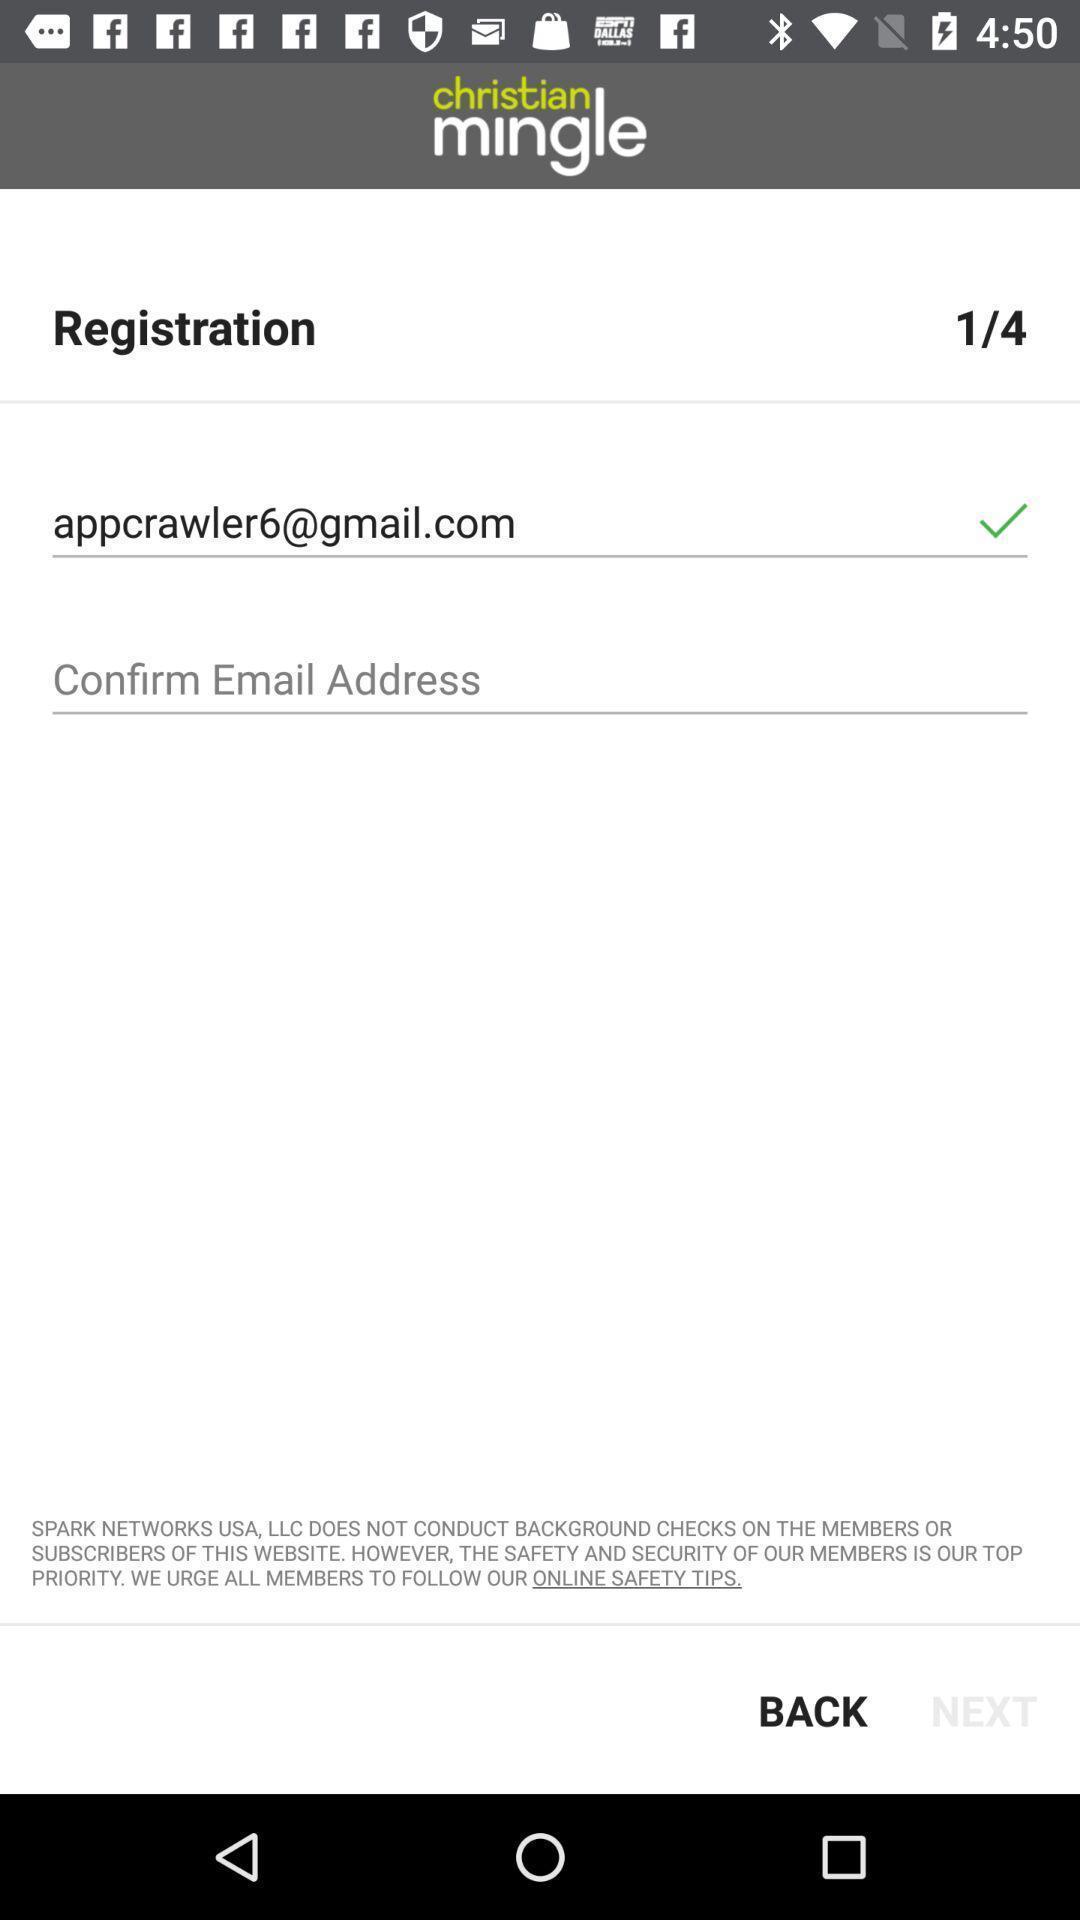Describe the content in this image. Page showing email address option. 